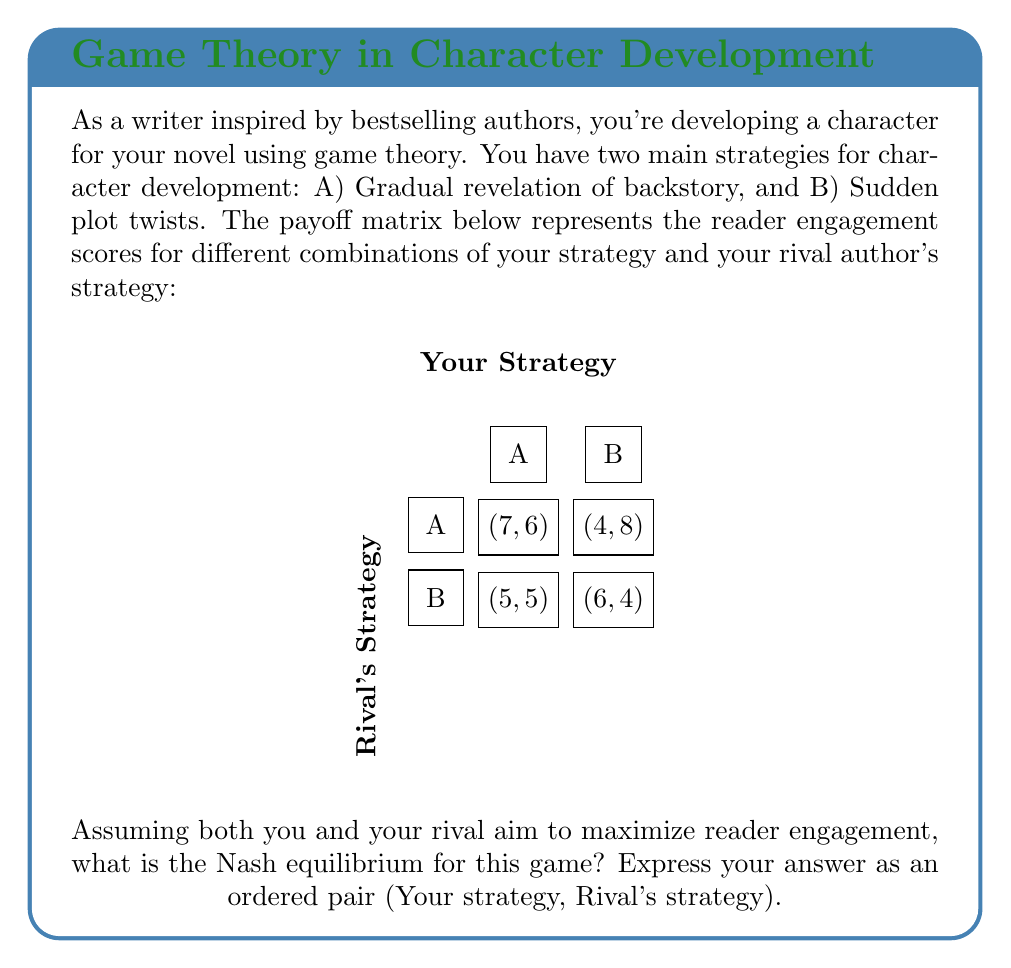Could you help me with this problem? To find the Nash equilibrium, we need to analyze each player's best response to the other's strategy:

1) Your perspective:
   - If Rival chooses A:
     A gives you 7, B gives you 4. Best response: A
   - If Rival chooses B:
     A gives you 5, B gives you 6. Best response: B

2) Rival's perspective:
   - If You choose A:
     A gives them 6, B gives them 5. Best response: A
   - If You choose B:
     A gives them 8, B gives them 4. Best response: A

3) Nash equilibrium occurs when both players are playing their best response to the other's strategy.

4) From the analysis:
   - (A,A) is stable: If you're playing A, Rival's best response is A. If Rival is playing A, your best response is A.
   - (B,A) is not stable: If Rival is playing A, your best response is A, not B.
   - (A,B) is not stable: If you're playing A, Rival's best response is A, not B.
   - (B,B) is not stable: If you're playing B, Rival's best response is A, not B.

5) Therefore, the only Nash equilibrium is (A,A).

In the context of the game, this means both you and your rival will opt for gradual revelation of backstory as your optimal strategy for character development.
Answer: (A,A) 